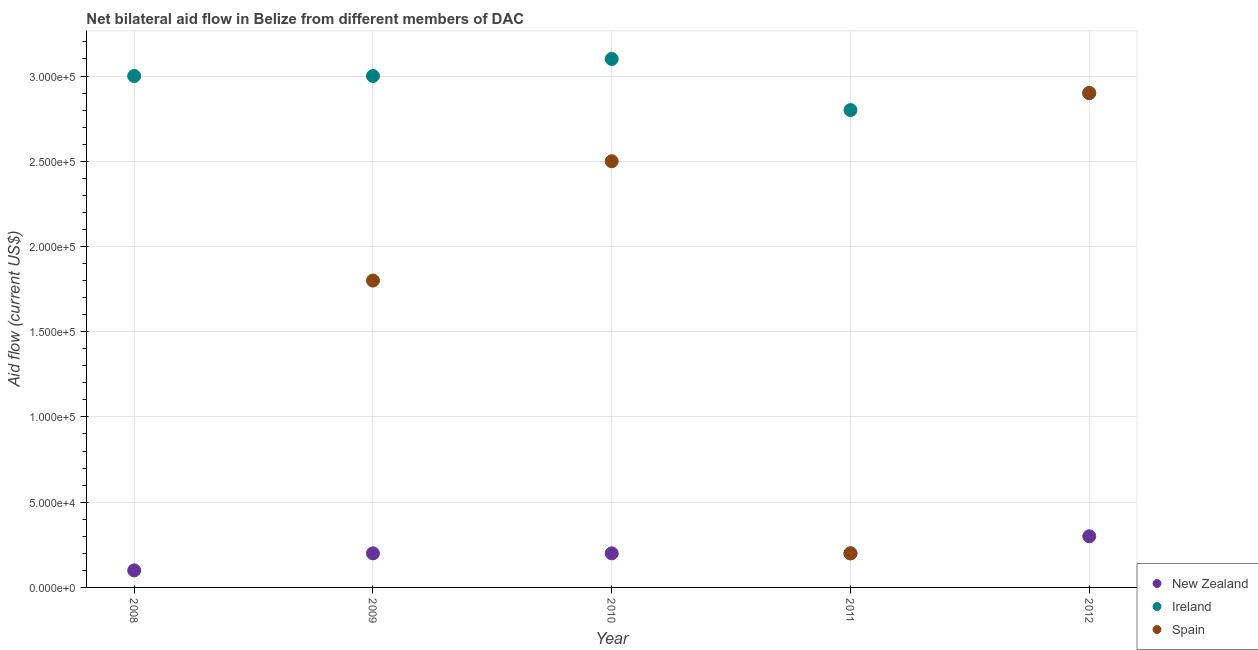What is the amount of aid provided by new zealand in 2011?
Provide a succinct answer. 2.00e+04. Across all years, what is the maximum amount of aid provided by new zealand?
Provide a short and direct response. 3.00e+04. In which year was the amount of aid provided by new zealand maximum?
Keep it short and to the point. 2012. What is the total amount of aid provided by spain in the graph?
Offer a very short reply. 7.40e+05. What is the difference between the amount of aid provided by new zealand in 2008 and that in 2011?
Make the answer very short. -10000. What is the difference between the amount of aid provided by new zealand in 2010 and the amount of aid provided by spain in 2009?
Give a very brief answer. -1.60e+05. What is the average amount of aid provided by ireland per year?
Give a very brief answer. 2.96e+05. In the year 2008, what is the difference between the amount of aid provided by new zealand and amount of aid provided by ireland?
Your response must be concise. -2.90e+05. In how many years, is the amount of aid provided by new zealand greater than 130000 US$?
Provide a short and direct response. 0. What is the ratio of the amount of aid provided by ireland in 2010 to that in 2012?
Keep it short and to the point. 1.07. Is the difference between the amount of aid provided by spain in 2009 and 2011 greater than the difference between the amount of aid provided by new zealand in 2009 and 2011?
Your answer should be very brief. Yes. What is the difference between the highest and the second highest amount of aid provided by ireland?
Your answer should be very brief. 10000. What is the difference between the highest and the lowest amount of aid provided by spain?
Your response must be concise. 2.90e+05. Is the amount of aid provided by ireland strictly greater than the amount of aid provided by new zealand over the years?
Keep it short and to the point. Yes. Are the values on the major ticks of Y-axis written in scientific E-notation?
Provide a short and direct response. Yes. Does the graph contain any zero values?
Keep it short and to the point. Yes. Does the graph contain grids?
Offer a terse response. Yes. How are the legend labels stacked?
Offer a terse response. Vertical. What is the title of the graph?
Offer a very short reply. Net bilateral aid flow in Belize from different members of DAC. Does "Taxes on income" appear as one of the legend labels in the graph?
Offer a very short reply. No. What is the label or title of the X-axis?
Give a very brief answer. Year. What is the Aid flow (current US$) of New Zealand in 2008?
Your answer should be very brief. 10000. What is the Aid flow (current US$) of New Zealand in 2009?
Your answer should be compact. 2.00e+04. What is the Aid flow (current US$) of Ireland in 2009?
Your response must be concise. 3.00e+05. What is the Aid flow (current US$) in New Zealand in 2011?
Provide a short and direct response. 2.00e+04. What is the Aid flow (current US$) in Ireland in 2011?
Your response must be concise. 2.80e+05. What is the Aid flow (current US$) of Spain in 2011?
Your response must be concise. 2.00e+04. What is the Aid flow (current US$) in New Zealand in 2012?
Ensure brevity in your answer.  3.00e+04. What is the Aid flow (current US$) of Ireland in 2012?
Give a very brief answer. 2.90e+05. Across all years, what is the maximum Aid flow (current US$) in New Zealand?
Provide a short and direct response. 3.00e+04. Across all years, what is the maximum Aid flow (current US$) in Ireland?
Offer a terse response. 3.10e+05. Across all years, what is the maximum Aid flow (current US$) of Spain?
Offer a terse response. 2.90e+05. Across all years, what is the minimum Aid flow (current US$) of New Zealand?
Offer a terse response. 10000. Across all years, what is the minimum Aid flow (current US$) in Ireland?
Offer a very short reply. 2.80e+05. Across all years, what is the minimum Aid flow (current US$) of Spain?
Give a very brief answer. 0. What is the total Aid flow (current US$) of Ireland in the graph?
Your answer should be compact. 1.48e+06. What is the total Aid flow (current US$) in Spain in the graph?
Keep it short and to the point. 7.40e+05. What is the difference between the Aid flow (current US$) of New Zealand in 2008 and that in 2009?
Your response must be concise. -10000. What is the difference between the Aid flow (current US$) of New Zealand in 2008 and that in 2010?
Your answer should be compact. -10000. What is the difference between the Aid flow (current US$) of New Zealand in 2008 and that in 2011?
Your answer should be very brief. -10000. What is the difference between the Aid flow (current US$) of Ireland in 2009 and that in 2010?
Your response must be concise. -10000. What is the difference between the Aid flow (current US$) in Spain in 2009 and that in 2010?
Ensure brevity in your answer.  -7.00e+04. What is the difference between the Aid flow (current US$) of New Zealand in 2009 and that in 2011?
Make the answer very short. 0. What is the difference between the Aid flow (current US$) of Ireland in 2009 and that in 2011?
Provide a short and direct response. 2.00e+04. What is the difference between the Aid flow (current US$) of Spain in 2009 and that in 2012?
Ensure brevity in your answer.  -1.10e+05. What is the difference between the Aid flow (current US$) in Spain in 2010 and that in 2011?
Your answer should be very brief. 2.30e+05. What is the difference between the Aid flow (current US$) of Ireland in 2010 and that in 2012?
Ensure brevity in your answer.  2.00e+04. What is the difference between the Aid flow (current US$) of Ireland in 2011 and that in 2012?
Provide a succinct answer. -10000. What is the difference between the Aid flow (current US$) of New Zealand in 2008 and the Aid flow (current US$) of Spain in 2009?
Your answer should be compact. -1.70e+05. What is the difference between the Aid flow (current US$) of New Zealand in 2008 and the Aid flow (current US$) of Spain in 2010?
Ensure brevity in your answer.  -2.40e+05. What is the difference between the Aid flow (current US$) in New Zealand in 2008 and the Aid flow (current US$) in Ireland in 2012?
Give a very brief answer. -2.80e+05. What is the difference between the Aid flow (current US$) in New Zealand in 2008 and the Aid flow (current US$) in Spain in 2012?
Make the answer very short. -2.80e+05. What is the difference between the Aid flow (current US$) in New Zealand in 2009 and the Aid flow (current US$) in Ireland in 2011?
Your answer should be very brief. -2.60e+05. What is the difference between the Aid flow (current US$) in Ireland in 2009 and the Aid flow (current US$) in Spain in 2011?
Offer a very short reply. 2.80e+05. What is the difference between the Aid flow (current US$) in New Zealand in 2009 and the Aid flow (current US$) in Ireland in 2012?
Give a very brief answer. -2.70e+05. What is the difference between the Aid flow (current US$) of New Zealand in 2010 and the Aid flow (current US$) of Ireland in 2011?
Your answer should be very brief. -2.60e+05. What is the difference between the Aid flow (current US$) in New Zealand in 2010 and the Aid flow (current US$) in Spain in 2011?
Give a very brief answer. 0. What is the difference between the Aid flow (current US$) of Ireland in 2010 and the Aid flow (current US$) of Spain in 2011?
Keep it short and to the point. 2.90e+05. What is the difference between the Aid flow (current US$) of New Zealand in 2010 and the Aid flow (current US$) of Ireland in 2012?
Keep it short and to the point. -2.70e+05. What is the difference between the Aid flow (current US$) of Ireland in 2010 and the Aid flow (current US$) of Spain in 2012?
Your answer should be very brief. 2.00e+04. What is the difference between the Aid flow (current US$) in Ireland in 2011 and the Aid flow (current US$) in Spain in 2012?
Your answer should be compact. -10000. What is the average Aid flow (current US$) of New Zealand per year?
Give a very brief answer. 2.00e+04. What is the average Aid flow (current US$) in Ireland per year?
Your response must be concise. 2.96e+05. What is the average Aid flow (current US$) in Spain per year?
Provide a succinct answer. 1.48e+05. In the year 2009, what is the difference between the Aid flow (current US$) of New Zealand and Aid flow (current US$) of Ireland?
Make the answer very short. -2.80e+05. In the year 2010, what is the difference between the Aid flow (current US$) in New Zealand and Aid flow (current US$) in Spain?
Provide a short and direct response. -2.30e+05. In the year 2011, what is the difference between the Aid flow (current US$) in New Zealand and Aid flow (current US$) in Ireland?
Your response must be concise. -2.60e+05. In the year 2011, what is the difference between the Aid flow (current US$) of New Zealand and Aid flow (current US$) of Spain?
Provide a succinct answer. 0. In the year 2012, what is the difference between the Aid flow (current US$) of Ireland and Aid flow (current US$) of Spain?
Make the answer very short. 0. What is the ratio of the Aid flow (current US$) in Ireland in 2008 to that in 2010?
Provide a short and direct response. 0.97. What is the ratio of the Aid flow (current US$) in New Zealand in 2008 to that in 2011?
Your response must be concise. 0.5. What is the ratio of the Aid flow (current US$) of Ireland in 2008 to that in 2011?
Provide a short and direct response. 1.07. What is the ratio of the Aid flow (current US$) of Ireland in 2008 to that in 2012?
Your answer should be very brief. 1.03. What is the ratio of the Aid flow (current US$) in New Zealand in 2009 to that in 2010?
Make the answer very short. 1. What is the ratio of the Aid flow (current US$) in Spain in 2009 to that in 2010?
Your response must be concise. 0.72. What is the ratio of the Aid flow (current US$) in New Zealand in 2009 to that in 2011?
Offer a very short reply. 1. What is the ratio of the Aid flow (current US$) of Ireland in 2009 to that in 2011?
Offer a terse response. 1.07. What is the ratio of the Aid flow (current US$) in New Zealand in 2009 to that in 2012?
Provide a short and direct response. 0.67. What is the ratio of the Aid flow (current US$) of Ireland in 2009 to that in 2012?
Provide a short and direct response. 1.03. What is the ratio of the Aid flow (current US$) in Spain in 2009 to that in 2012?
Keep it short and to the point. 0.62. What is the ratio of the Aid flow (current US$) of New Zealand in 2010 to that in 2011?
Offer a terse response. 1. What is the ratio of the Aid flow (current US$) of Ireland in 2010 to that in 2011?
Make the answer very short. 1.11. What is the ratio of the Aid flow (current US$) in Spain in 2010 to that in 2011?
Your answer should be compact. 12.5. What is the ratio of the Aid flow (current US$) in New Zealand in 2010 to that in 2012?
Give a very brief answer. 0.67. What is the ratio of the Aid flow (current US$) in Ireland in 2010 to that in 2012?
Your answer should be very brief. 1.07. What is the ratio of the Aid flow (current US$) in Spain in 2010 to that in 2012?
Your response must be concise. 0.86. What is the ratio of the Aid flow (current US$) of Ireland in 2011 to that in 2012?
Your answer should be very brief. 0.97. What is the ratio of the Aid flow (current US$) in Spain in 2011 to that in 2012?
Keep it short and to the point. 0.07. What is the difference between the highest and the second highest Aid flow (current US$) in New Zealand?
Ensure brevity in your answer.  10000. What is the difference between the highest and the lowest Aid flow (current US$) in Ireland?
Offer a terse response. 3.00e+04. What is the difference between the highest and the lowest Aid flow (current US$) in Spain?
Give a very brief answer. 2.90e+05. 